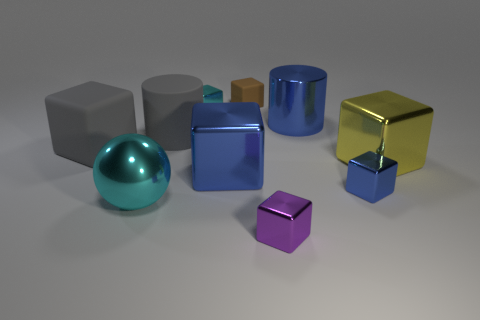Is there any other thing that is the same shape as the large cyan metallic object?
Your response must be concise. No. What number of purple objects are either big rubber objects or big rubber cylinders?
Ensure brevity in your answer.  0. Is the material of the large block in front of the yellow object the same as the brown cube?
Make the answer very short. No. What number of other objects are the same material as the tiny cyan object?
Your answer should be compact. 6. What is the big sphere made of?
Your response must be concise. Metal. What is the size of the matte cube that is on the right side of the cyan block?
Your answer should be very brief. Small. What number of cyan metal things are on the left side of the cube that is behind the tiny cyan thing?
Make the answer very short. 2. Do the tiny object on the left side of the small matte thing and the large metal thing in front of the tiny blue object have the same shape?
Your response must be concise. No. What number of things are left of the big blue cube and in front of the tiny blue block?
Your response must be concise. 1. Is there a small cube of the same color as the big shiny cylinder?
Give a very brief answer. Yes. 